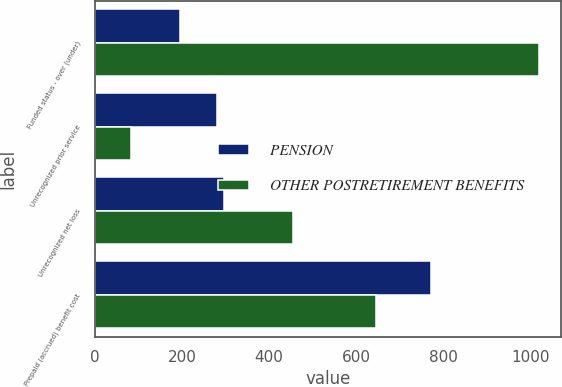Convert chart. <chart><loc_0><loc_0><loc_500><loc_500><stacked_bar_chart><ecel><fcel>Funded status - over (under)<fcel>Unrecognized prior service<fcel>Unrecognized net loss<fcel>Prepaid (accrued) benefit cost<nl><fcel>PENSION<fcel>196<fcel>280<fcel>296<fcel>772<nl><fcel>OTHER POSTRETIREMENT BENEFITS<fcel>1019<fcel>82<fcel>455<fcel>646<nl></chart> 